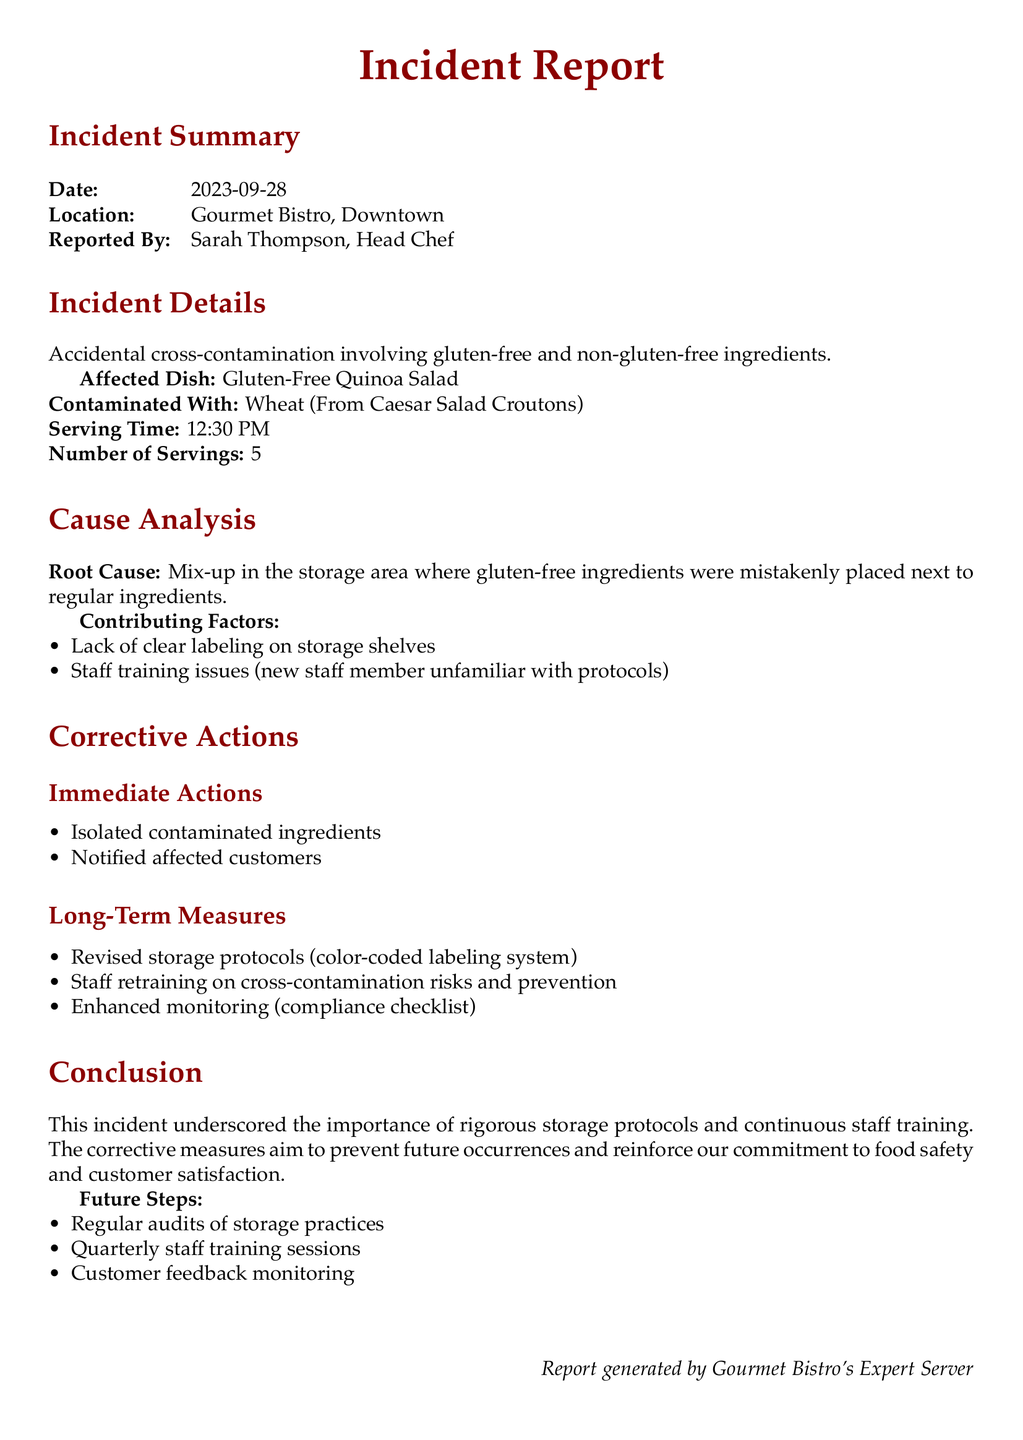what is the date of the incident? The date of the incident is provided in the incident summary section.
Answer: 2023-09-28 who reported the incident? The identity of the person who reported the incident is indicated in the summary section.
Answer: Sarah Thompson what was the affected dish? The dish that was affected by cross-contamination is specified in the document.
Answer: Gluten-Free Quinoa Salad what was the root cause of the incident? The document outlines the main reason for the incident in the cause analysis section.
Answer: Mix-up in the storage area how many servings were contaminated? The total number of contaminated servings is explicitly mentioned in the incident details.
Answer: 5 what corrective action was taken to isolate the issue? The document lists immediate actions taken following the incident.
Answer: Isolated contaminated ingredients which labeling system was introduced? The long-term measure section identifies the new labeling system implemented.
Answer: Color-coded labeling system what type of training is mentioned for staff? The corrective actions detail the kind of training emphasized for staff members.
Answer: Staff retraining on cross-contamination risks what will be done quarterly to improve safety? The future steps outline regular actions planned to ensure food safety.
Answer: Quarterly staff training sessions 